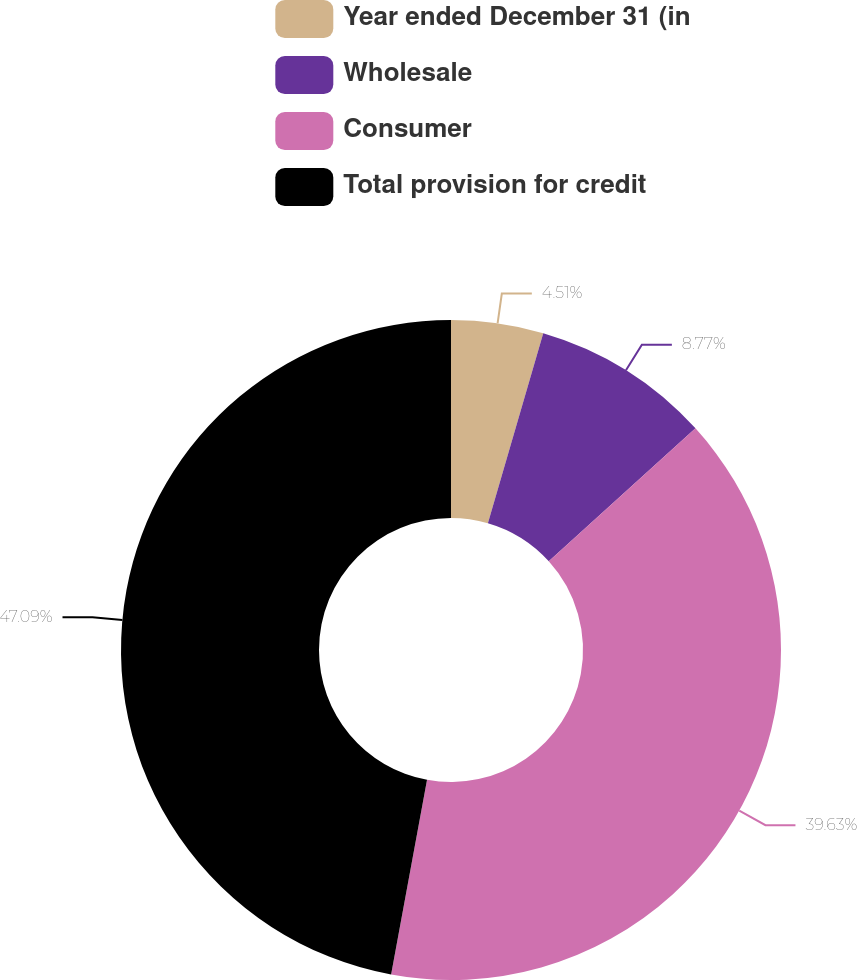Convert chart. <chart><loc_0><loc_0><loc_500><loc_500><pie_chart><fcel>Year ended December 31 (in<fcel>Wholesale<fcel>Consumer<fcel>Total provision for credit<nl><fcel>4.51%<fcel>8.77%<fcel>39.63%<fcel>47.1%<nl></chart> 